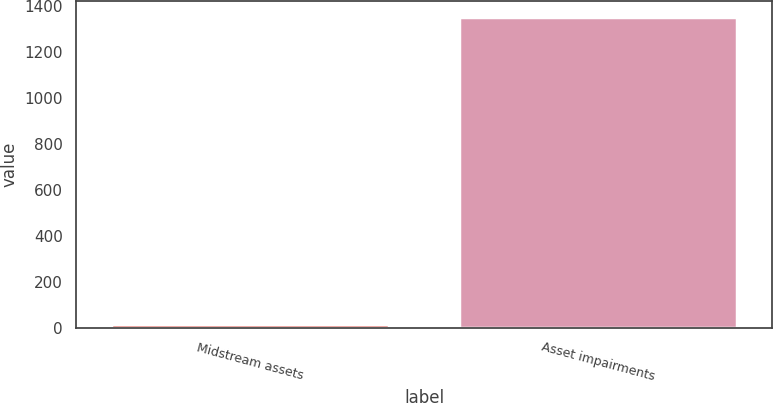<chart> <loc_0><loc_0><loc_500><loc_500><bar_chart><fcel>Midstream assets<fcel>Asset impairments<nl><fcel>14<fcel>1353<nl></chart> 